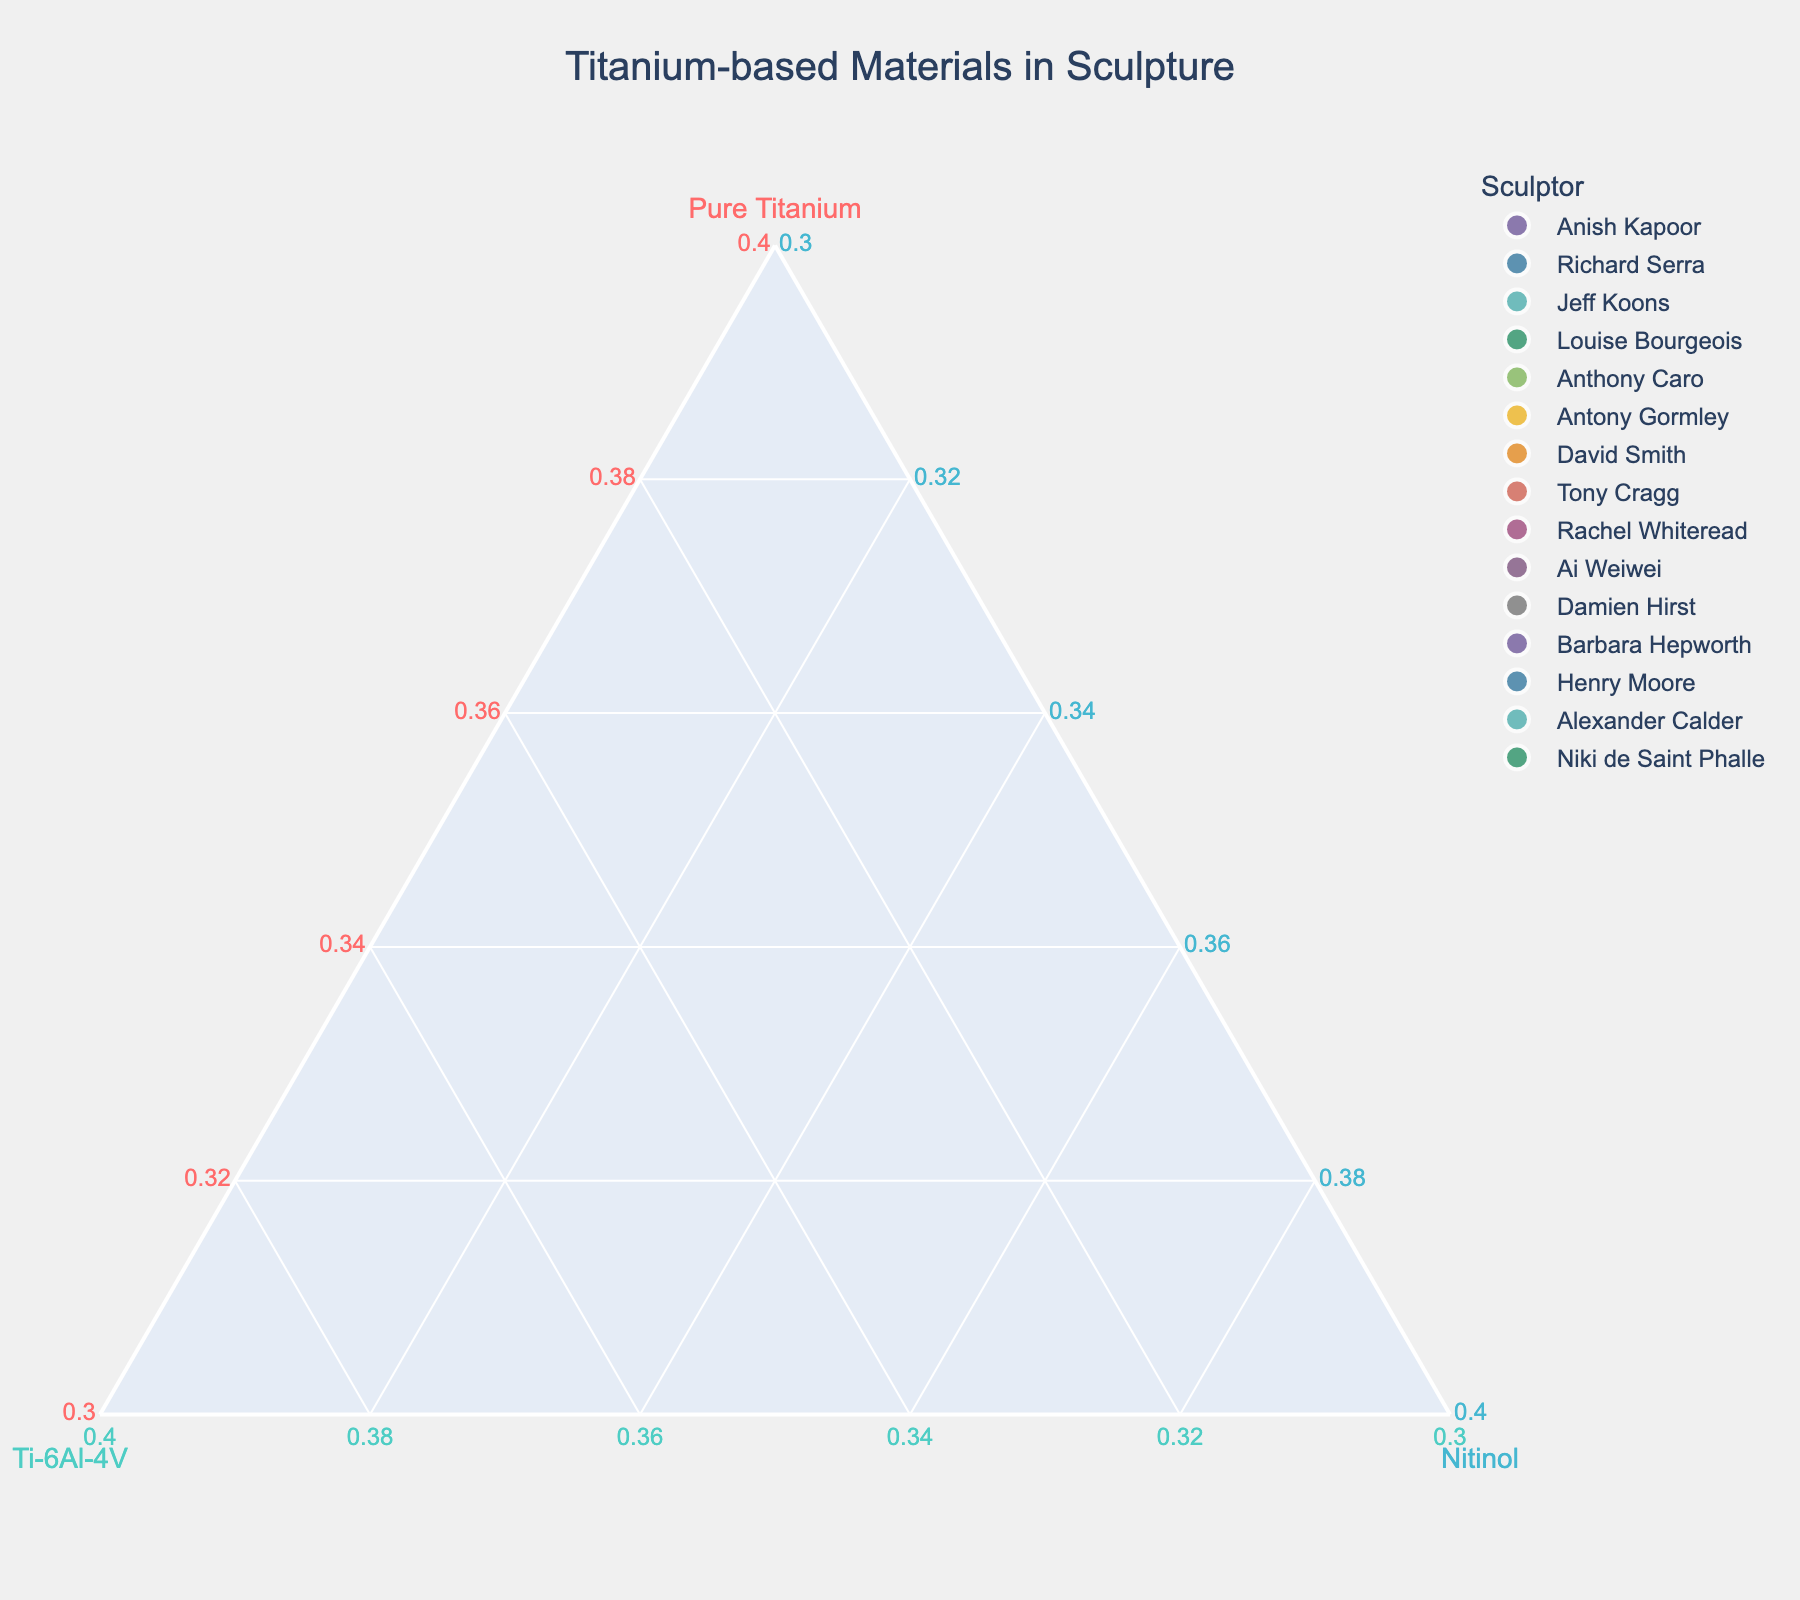What is the title of the plot? The title is located at the top of the plot. It clearly states what the plot is representing.
Answer: Titanium-based Materials in Sculpture How many sculptors are represented in the plot? The number of data points on the plot corresponds to the number of sculptors. Count every point.
Answer: 15 Which sculptor uses the highest proportion of Pure Titanium? Identify the point that is closest to the vertex labeled "Pure Titanium" on the ternary plot.
Answer: Barbara Hepworth Which two sculptors have an equal proportion of Nitinol in their sculptures? Look for data points that share the same value along the Nitinol axis.
Answer: Anish Kapoor and Antony Gormley Who has a higher proportion of Ti-6Al-4V, Richard Serra or Jeff Koons? Compare the positions of their data points along the Ti-6Al-4V axis.
Answer: Jeff Koons What is the average proportion of Pure Titanium used by Richard Serra and Jeff Koons? Add the proportion of Pure Titanium used by Richard Serra and Jeff Koons and divide by 2. Richard Serra: 40%, Jeff Koons: 30%. So, (40 + 30)/2 = 35%
Answer: 35% Which sculptor has the smallest proportion of Nitinol in their sculptures? Identify the point that is furthest from the vertex labeled "Nitinol" on the ternary plot.
Answer: Richard Serra Is there any sculptor who uses an equal proportion of all three materials? An equal proportion would place the data point at the center of the ternary plot. Examine the central region.
Answer: No Which sculptor utilizes a higher proportion of Ti-6Al-4V compared to Pure Titanium? Compare the positions along the Ti-6Al-4V and Pure Titanium axes for each point.
Answer: Damien Hirst What is the combined average proportion of Ti-6Al-4V and Nitinol used by Anish Kapoor? Add the proportions of Ti-6Al-4V and Nitinol used by Anish Kapoor and divide by the number of materials. (25 + 10)/2 = 17.5%
Answer: 17.5% 